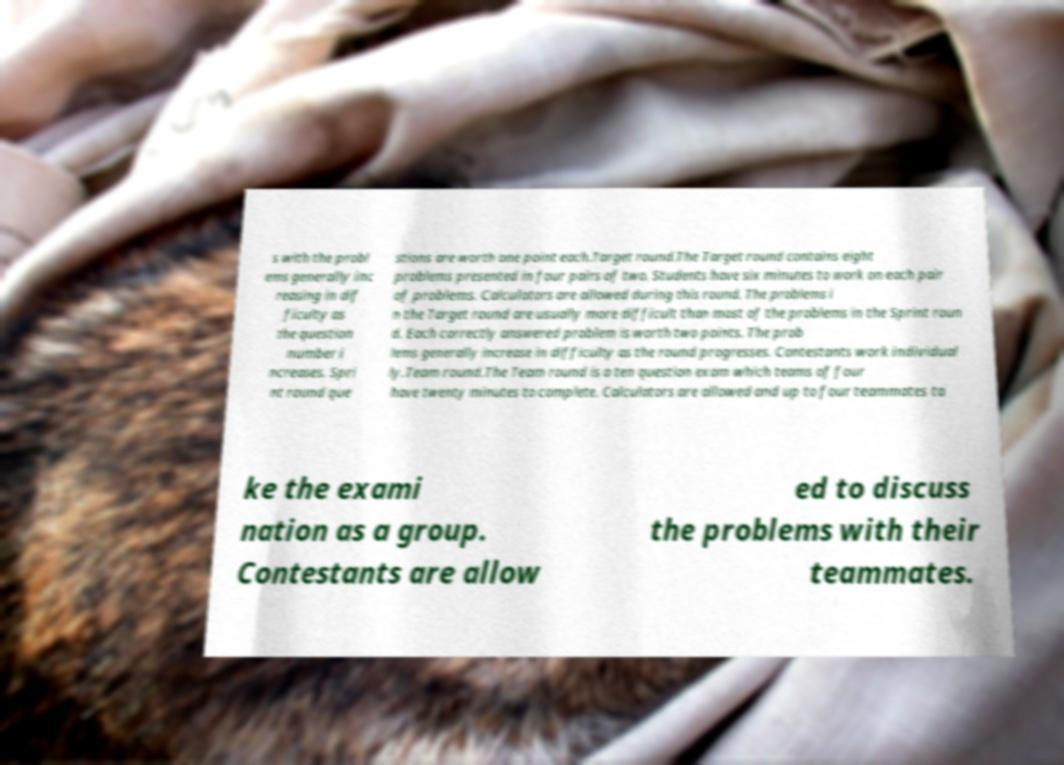What messages or text are displayed in this image? I need them in a readable, typed format. s with the probl ems generally inc reasing in dif ficulty as the question number i ncreases. Spri nt round que stions are worth one point each.Target round.The Target round contains eight problems presented in four pairs of two. Students have six minutes to work on each pair of problems. Calculators are allowed during this round. The problems i n the Target round are usually more difficult than most of the problems in the Sprint roun d. Each correctly answered problem is worth two points. The prob lems generally increase in difficulty as the round progresses. Contestants work individual ly.Team round.The Team round is a ten question exam which teams of four have twenty minutes to complete. Calculators are allowed and up to four teammates ta ke the exami nation as a group. Contestants are allow ed to discuss the problems with their teammates. 